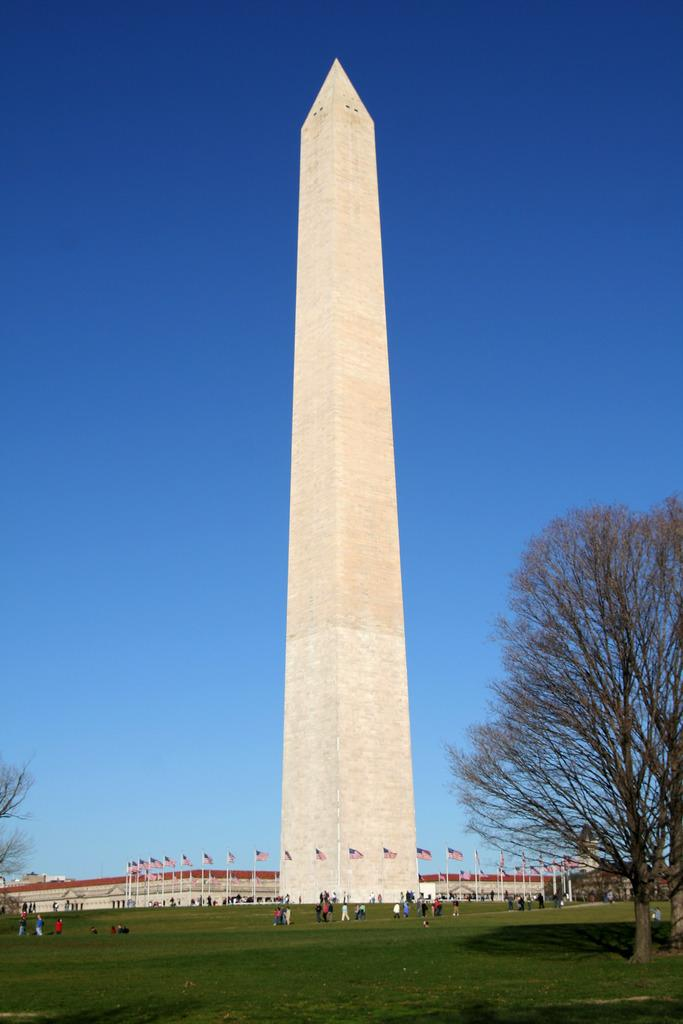What type of vegetation is on the right side of the image? There are trees on the right side of the image. What are the people in the background doing? The people in the background are standing and walking on the grass. What can be seen in the background besides the people? There are poles, flags, a tower, a building, and the sky visible in the background. What type of food is being served during the recess in the image? There is no recess or food present in the image. What scene is depicted in the image? The image does not depict a specific scene; it shows trees, people, poles, flags, a tower, a building, and the sky. 